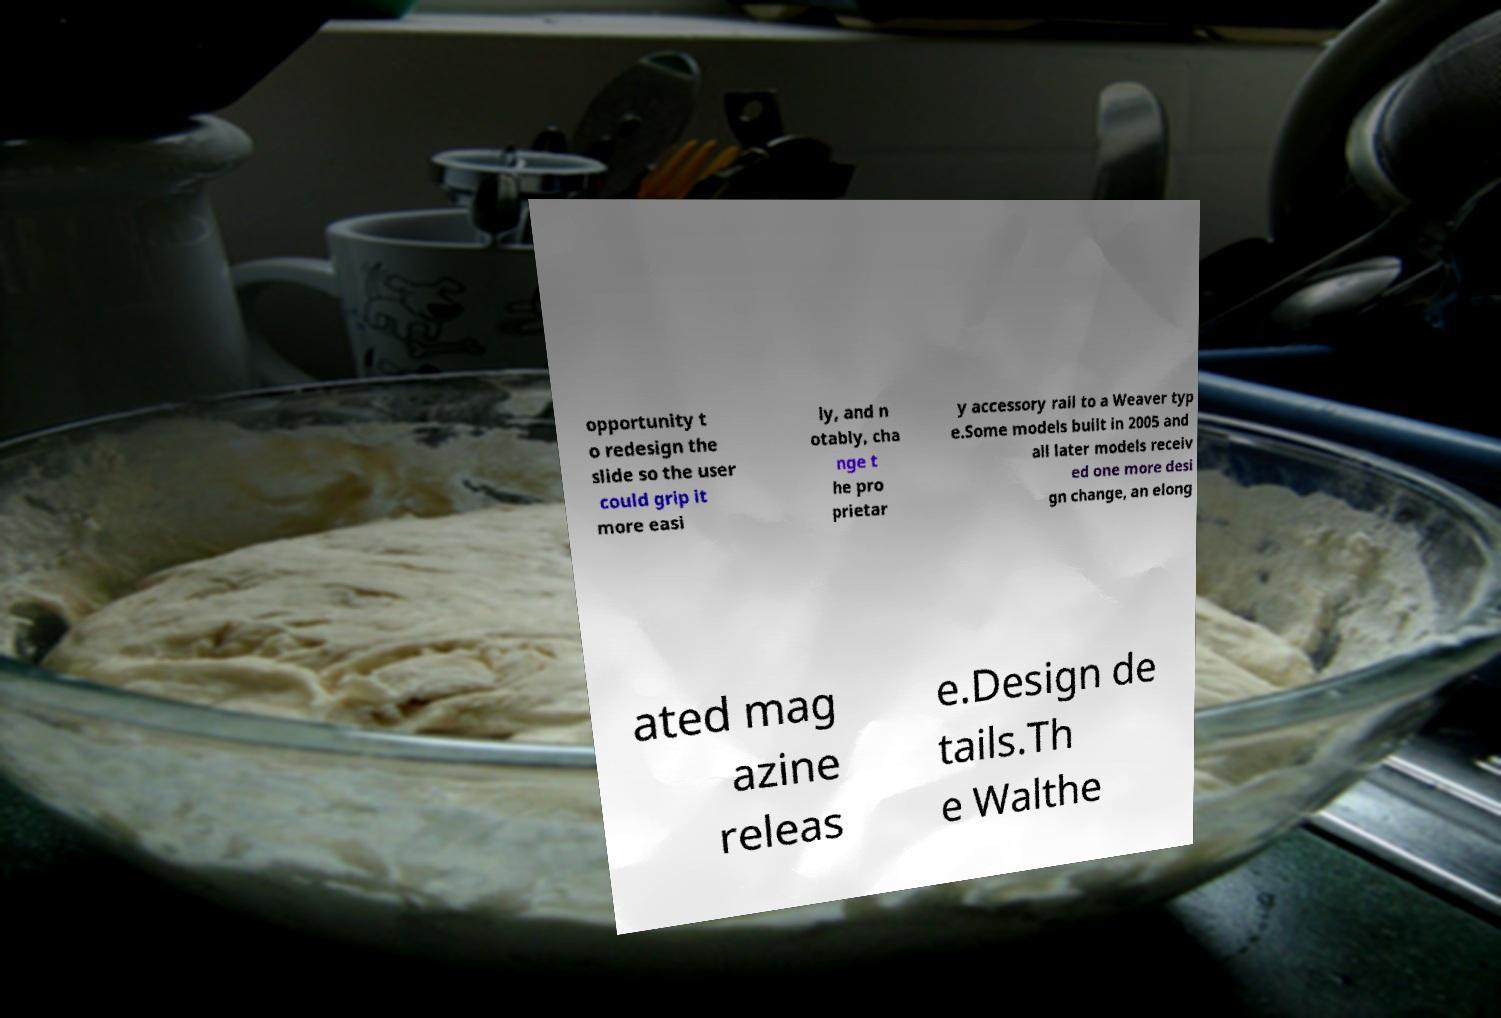Please identify and transcribe the text found in this image. opportunity t o redesign the slide so the user could grip it more easi ly, and n otably, cha nge t he pro prietar y accessory rail to a Weaver typ e.Some models built in 2005 and all later models receiv ed one more desi gn change, an elong ated mag azine releas e.Design de tails.Th e Walthe 